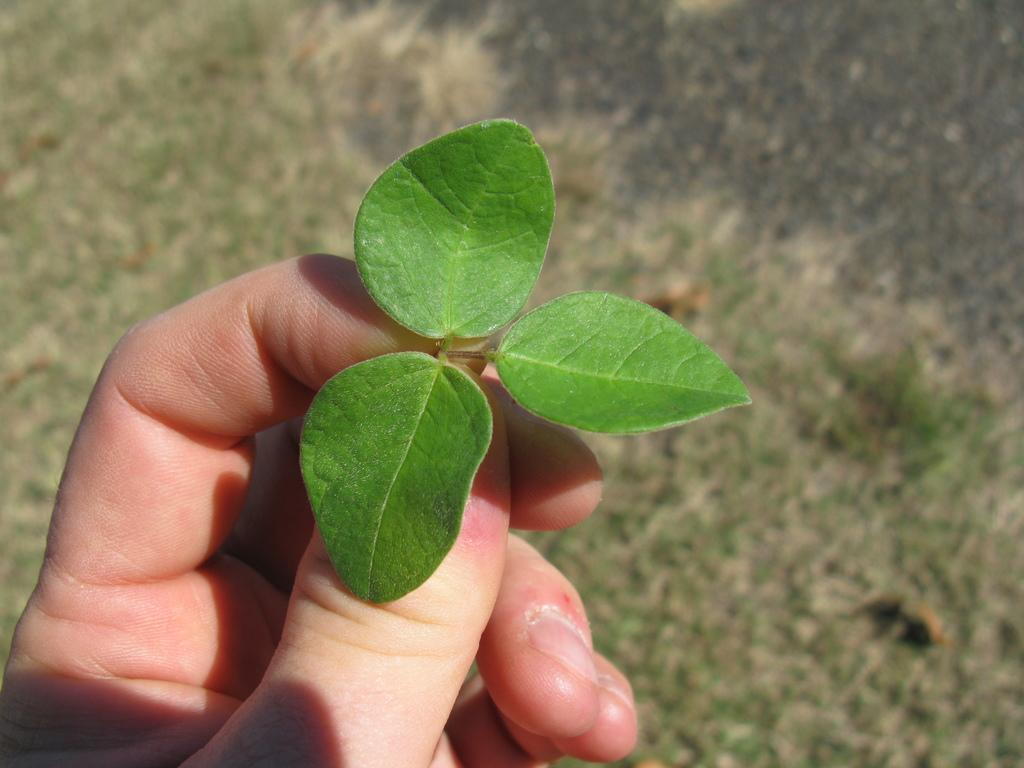What is the person holding in the image? There is a person's hand holding leaves in the image. What type of vegetation can be seen in the image? There is grass visible in the image. What color is the blood on the person's sock in the image? There is no blood or sock present in the image; it only shows a person's hand holding leaves and grass. 